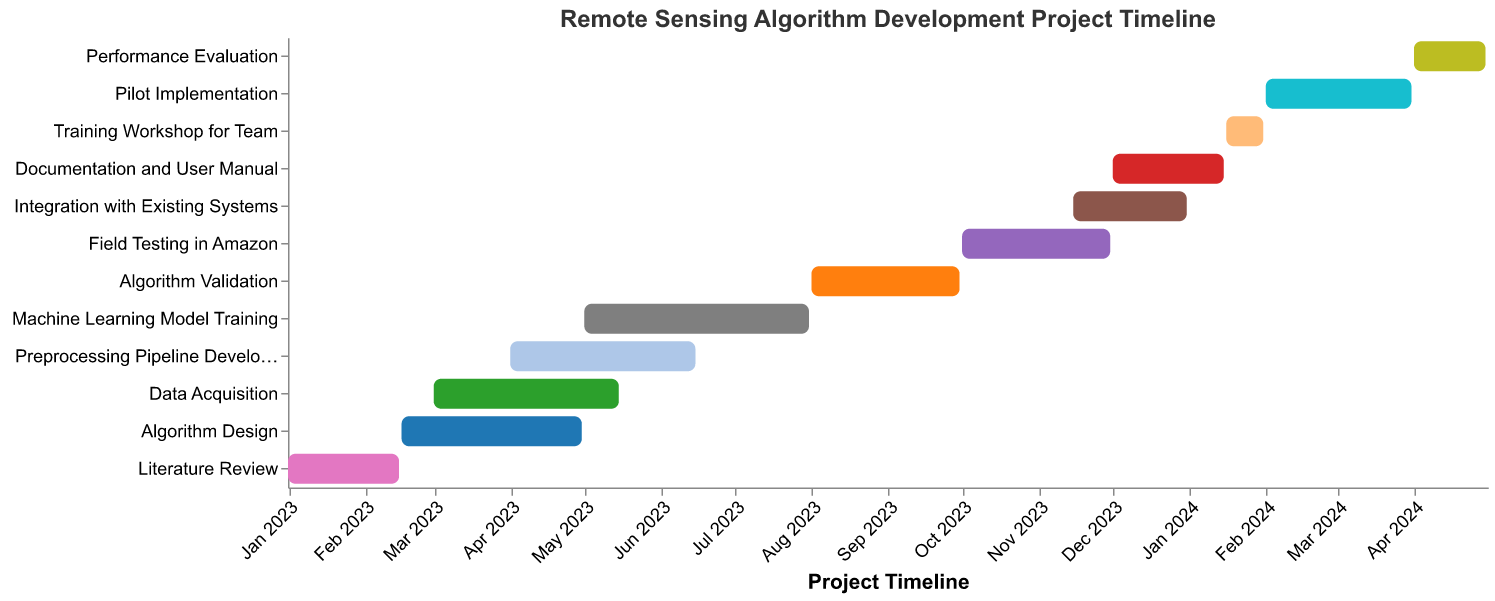What is the title of the Gantt Chart? The title of the chart is typically found at the top of the figure, usually formatted in bold to stand out. It provides an overview of what the chart is about.
Answer: Remote Sensing Algorithm Development Project Timeline How many tasks are detailed in the Gantt Chart? To find out the number of tasks, count the distinct bars on the y-axis, each representing a specific task.
Answer: 12 Which task spans the longest duration and what is it? To identify the longest duration task, visually compare the length of each bar in the chart. The longest bar represents the task with the most extended timeline.
Answer: Machine Learning Model Training What is the start and end date for the "Field Testing in Amazon" task? Look at the "Field Testing in Amazon" bar and hover over or examine the axis labels and tooltips displayed.
Answer: October 1, 2023, to November 30, 2023 When does the "Algorithm Design" task begin and end? Refer to the "Algorithm Design" task bar and check the axis labels or tooltips that indicate the start and end dates.
Answer: February 16, 2023, to April 30, 2023 Which two tasks overlap during the month of December 2023? To identify overlapping tasks, look for bars that occupy the same horizontal space during the specified time period. Check December 2023 and see which tasks' bars coincide.
Answer: Integration with Existing Systems and Documentation and User Manual How long is the "Training Workshop for Team" task? Determine the length of the "Training Workshop for Team" bar. Calculate the difference in days between the start and end date provided by the tooltips or axis labels.
Answer: 15 days Compare the duration of "Preprocessing Pipeline Development" and "Pilot Implementation". Which takes longer? Measure the length of each bar to compare their durations visually. Calculate the duration of time each task covers from start to end date.
Answer: Preprocessing Pipeline Development takes longer Which tasks are scheduled to begin after August 2023? Identify tasks starting after August 2023 by looking at the start dates of each bar and filtering out those that start later than August 1, 2023.
Answer: Algorithm Validation, Field Testing in Amazon, Integration with Existing Systems, Documentation and User Manual, Training Workshop for Team, Pilot Implementation, Performance Evaluation What is the time gap between the end of "Machine Learning Model Training" and the start of "Algorithm Validation"? Find the end date of "Machine Learning Model Training" and the start date of "Algorithm Validation". Calculate the number of days or the gap between these dates.
Answer: 1 day 